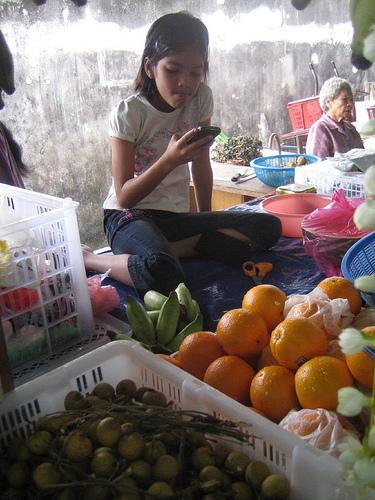What color are the plastic containers?
Concise answer only. White. Are the plants alive?
Keep it brief. No. What kind of tool is in front of the girl?
Be succinct. Scissors. What are the orange objects?
Short answer required. Oranges. How much money is being exchanged?
Write a very short answer. 0. 